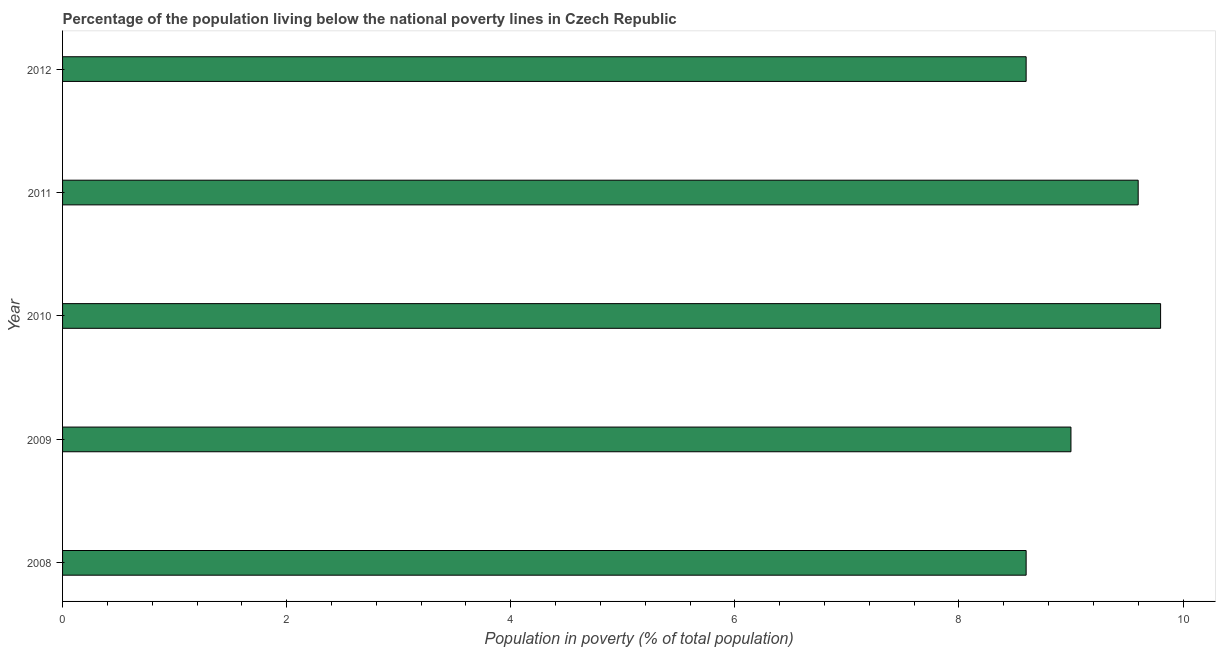Does the graph contain any zero values?
Keep it short and to the point. No. What is the title of the graph?
Your answer should be compact. Percentage of the population living below the national poverty lines in Czech Republic. What is the label or title of the X-axis?
Make the answer very short. Population in poverty (% of total population). What is the label or title of the Y-axis?
Make the answer very short. Year. Across all years, what is the maximum percentage of population living below poverty line?
Your response must be concise. 9.8. Across all years, what is the minimum percentage of population living below poverty line?
Offer a terse response. 8.6. In which year was the percentage of population living below poverty line minimum?
Offer a terse response. 2008. What is the sum of the percentage of population living below poverty line?
Offer a terse response. 45.6. What is the average percentage of population living below poverty line per year?
Give a very brief answer. 9.12. What is the median percentage of population living below poverty line?
Keep it short and to the point. 9. In how many years, is the percentage of population living below poverty line greater than 2 %?
Make the answer very short. 5. What is the ratio of the percentage of population living below poverty line in 2009 to that in 2011?
Your answer should be compact. 0.94. What is the difference between the highest and the second highest percentage of population living below poverty line?
Make the answer very short. 0.2. Is the sum of the percentage of population living below poverty line in 2009 and 2012 greater than the maximum percentage of population living below poverty line across all years?
Your answer should be compact. Yes. What is the difference between the highest and the lowest percentage of population living below poverty line?
Ensure brevity in your answer.  1.2. In how many years, is the percentage of population living below poverty line greater than the average percentage of population living below poverty line taken over all years?
Give a very brief answer. 2. Are all the bars in the graph horizontal?
Provide a short and direct response. Yes. What is the difference between two consecutive major ticks on the X-axis?
Provide a short and direct response. 2. What is the Population in poverty (% of total population) in 2010?
Your response must be concise. 9.8. What is the Population in poverty (% of total population) in 2011?
Give a very brief answer. 9.6. What is the Population in poverty (% of total population) in 2012?
Keep it short and to the point. 8.6. What is the difference between the Population in poverty (% of total population) in 2008 and 2011?
Offer a terse response. -1. What is the difference between the Population in poverty (% of total population) in 2008 and 2012?
Make the answer very short. 0. What is the difference between the Population in poverty (% of total population) in 2010 and 2011?
Keep it short and to the point. 0.2. What is the ratio of the Population in poverty (% of total population) in 2008 to that in 2009?
Provide a succinct answer. 0.96. What is the ratio of the Population in poverty (% of total population) in 2008 to that in 2010?
Give a very brief answer. 0.88. What is the ratio of the Population in poverty (% of total population) in 2008 to that in 2011?
Keep it short and to the point. 0.9. What is the ratio of the Population in poverty (% of total population) in 2008 to that in 2012?
Provide a succinct answer. 1. What is the ratio of the Population in poverty (% of total population) in 2009 to that in 2010?
Your response must be concise. 0.92. What is the ratio of the Population in poverty (% of total population) in 2009 to that in 2011?
Your answer should be compact. 0.94. What is the ratio of the Population in poverty (% of total population) in 2009 to that in 2012?
Make the answer very short. 1.05. What is the ratio of the Population in poverty (% of total population) in 2010 to that in 2012?
Keep it short and to the point. 1.14. What is the ratio of the Population in poverty (% of total population) in 2011 to that in 2012?
Your answer should be compact. 1.12. 